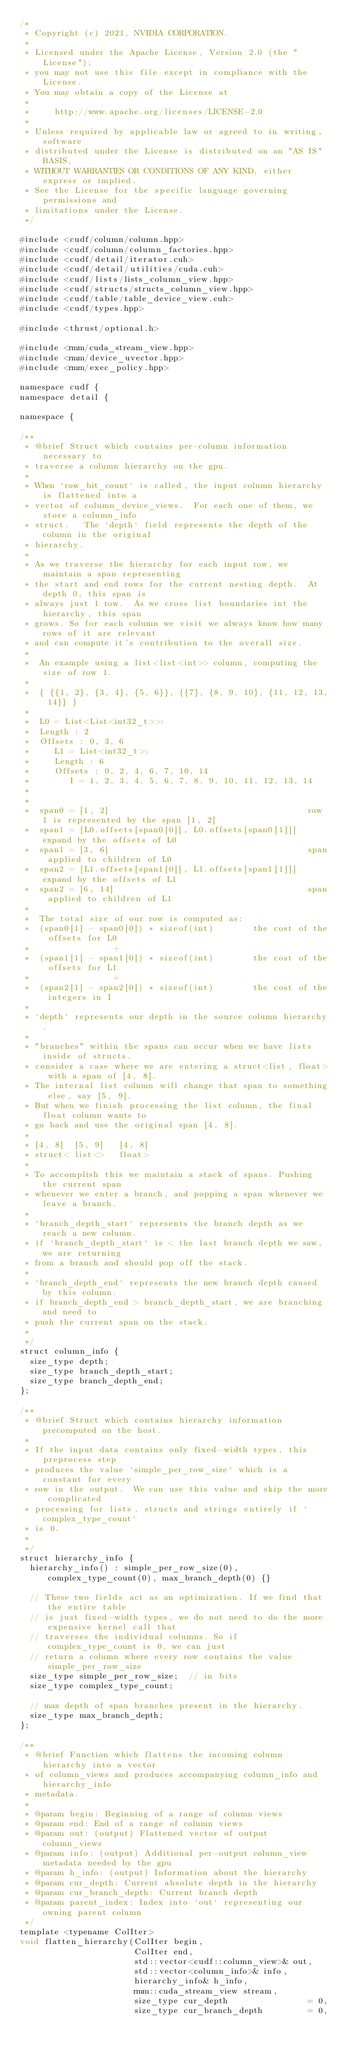<code> <loc_0><loc_0><loc_500><loc_500><_Cuda_>/*
 * Copyright (c) 2021, NVIDIA CORPORATION.
 *
 * Licensed under the Apache License, Version 2.0 (the "License");
 * you may not use this file except in compliance with the License.
 * You may obtain a copy of the License at
 *
 *     http://www.apache.org/licenses/LICENSE-2.0
 *
 * Unless required by applicable law or agreed to in writing, software
 * distributed under the License is distributed on an "AS IS" BASIS,
 * WITHOUT WARRANTIES OR CONDITIONS OF ANY KIND, either express or implied.
 * See the License for the specific language governing permissions and
 * limitations under the License.
 */

#include <cudf/column/column.hpp>
#include <cudf/column/column_factories.hpp>
#include <cudf/detail/iterator.cuh>
#include <cudf/detail/utilities/cuda.cuh>
#include <cudf/lists/lists_column_view.hpp>
#include <cudf/structs/structs_column_view.hpp>
#include <cudf/table/table_device_view.cuh>
#include <cudf/types.hpp>

#include <thrust/optional.h>

#include <rmm/cuda_stream_view.hpp>
#include <rmm/device_uvector.hpp>
#include <rmm/exec_policy.hpp>

namespace cudf {
namespace detail {

namespace {

/**
 * @brief Struct which contains per-column information necessary to
 * traverse a column hierarchy on the gpu.
 *
 * When `row_bit_count` is called, the input column hierarchy is flattened into a
 * vector of column_device_views.  For each one of them, we store a column_info
 * struct.   The `depth` field represents the depth of the column in the original
 * hierarchy.
 *
 * As we traverse the hierarchy for each input row, we maintain a span representing
 * the start and end rows for the current nesting depth.  At depth 0, this span is
 * always just 1 row.  As we cross list boundaries int the hierarchy, this span
 * grows. So for each column we visit we always know how many rows of it are relevant
 * and can compute it's contribution to the overall size.
 *
 *  An example using a list<list<int>> column, computing the size of row 1.
 *
 *  { {{1, 2}, {3, 4}, {5, 6}}, {{7}, {8, 9, 10}, {11, 12, 13, 14}} }
 *
 *  L0 = List<List<int32_t>>:
 *  Length : 2
 *  Offsets : 0, 3, 6
 *     L1 = List<int32_t>:
 *     Length : 6
 *     Offsets : 0, 2, 4, 6, 7, 10, 14
 *        I = 1, 2, 3, 4, 5, 6, 7, 8, 9, 10, 11, 12, 13, 14
 *
 *
 *  span0 = [1, 2]                                        row 1 is represented by the span [1, 2]
 *  span1 = [L0.offsets[span0[0]], L0.offsets[span0[1]]]  expand by the offsets of L0
 *  span1 = [3, 6]                                        span applied to children of L0
 *  span2 = [L1.offsets[span1[0]], L1.offsets[span1[1]]]  expand by the offsets of L1
 *  span2 = [6, 14]                                       span applied to children of L1
 *
 *  The total size of our row is computed as:
 *  (span0[1] - span0[0]) * sizeof(int)        the cost of the offsets for L0
 *                 +
 *  (span1[1] - span1[0]) * sizeof(int)        the cost of the offsets for L1
 *                 +
 *  (span2[1] - span2[0]) * sizeof(int)        the cost of the integers in I
 *
 * `depth` represents our depth in the source column hierarchy.
 *
 * "branches" within the spans can occur when we have lists inside of structs.
 * consider a case where we are entering a struct<list, float> with a span of [4, 8].
 * The internal list column will change that span to something else, say [5, 9].
 * But when we finish processing the list column, the final float column wants to
 * go back and use the original span [4, 8].
 *
 * [4, 8]  [5, 9]   [4, 8]
 * struct< list<>   float>
 *
 * To accomplish this we maintain a stack of spans. Pushing the current span
 * whenever we enter a branch, and popping a span whenever we leave a branch.
 *
 * `branch_depth_start` represents the branch depth as we reach a new column.
 * if `branch_depth_start` is < the last branch depth we saw, we are returning
 * from a branch and should pop off the stack.
 *
 * `branch_depth_end` represents the new branch depth caused by this column.
 * if branch_depth_end > branch_depth_start, we are branching and need to
 * push the current span on the stack.
 *
 */
struct column_info {
  size_type depth;
  size_type branch_depth_start;
  size_type branch_depth_end;
};

/**
 * @brief Struct which contains hierarchy information precomputed on the host.
 *
 * If the input data contains only fixed-width types, this preprocess step
 * produces the value `simple_per_row_size` which is a constant for every
 * row in the output.  We can use this value and skip the more complicated
 * processing for lists, structs and strings entirely if `complex_type_count`
 * is 0.
 *
 */
struct hierarchy_info {
  hierarchy_info() : simple_per_row_size(0), complex_type_count(0), max_branch_depth(0) {}

  // These two fields act as an optimization. If we find that the entire table
  // is just fixed-width types, we do not need to do the more expensive kernel call that
  // traverses the individual columns. So if complex_type_count is 0, we can just
  // return a column where every row contains the value simple_per_row_size
  size_type simple_per_row_size;  // in bits
  size_type complex_type_count;

  // max depth of span branches present in the hierarchy.
  size_type max_branch_depth;
};

/**
 * @brief Function which flattens the incoming column hierarchy into a vector
 * of column_views and produces accompanying column_info and hierarchy_info
 * metadata.
 *
 * @param begin: Beginning of a range of column views
 * @param end: End of a range of column views
 * @param out: (output) Flattened vector of output column_views
 * @param info: (output) Additional per-output column_view metadata needed by the gpu
 * @param h_info: (output) Information about the hierarchy
 * @param cur_depth: Current absolute depth in the hierarchy
 * @param cur_branch_depth: Current branch depth
 * @param parent_index: Index into `out` representing our owning parent column
 */
template <typename ColIter>
void flatten_hierarchy(ColIter begin,
                       ColIter end,
                       std::vector<cudf::column_view>& out,
                       std::vector<column_info>& info,
                       hierarchy_info& h_info,
                       rmm::cuda_stream_view stream,
                       size_type cur_depth                = 0,
                       size_type cur_branch_depth         = 0,</code> 